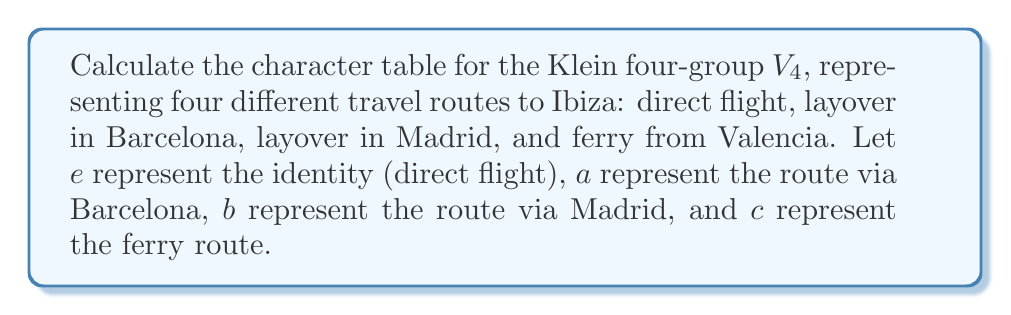Provide a solution to this math problem. To calculate the character table for the Klein four-group $V_4$, we'll follow these steps:

1) First, identify the conjugacy classes of $V_4$:
   Since $V_4$ is abelian, each element forms its own conjugacy class.
   Conjugacy classes: $\{e\}$, $\{a\}$, $\{b\}$, $\{c\}$

2) Determine the number of irreducible representations:
   The number of irreducible representations equals the number of conjugacy classes, which is 4.

3) The sum of squares of the dimensions of irreducible representations must equal the order of the group:
   $d_1^2 + d_2^2 + d_3^2 + d_4^2 = |V_4| = 4$

4) For an abelian group, all irreducible representations are 1-dimensional. So, we have four 1-dimensional representations.

5) Construct the character table:
   - The first row (trivial representation) is always all 1's.
   - For the remaining rows, we need to ensure orthogonality and that the characters form a group homomorphism.

6) The character table will look like this:

   $$\begin{array}{c|cccc}
      V_4 & e & a & b & c \\
      \hline
      \chi_1 & 1 & 1 & 1 & 1 \\
      \chi_2 & 1 & 1 & -1 & -1 \\
      \chi_3 & 1 & -1 & 1 & -1 \\
      \chi_4 & 1 & -1 & -1 & 1
   \end{array}$$

7) Verify orthogonality of rows and columns.

This character table represents how each "travel route" (group element) behaves under different representations, analogous to how a traveler might experience different aspects of the journey to Ibiza depending on the chosen route.
Answer: $$\begin{array}{c|cccc}
   V_4 & e & a & b & c \\
   \hline
   \chi_1 & 1 & 1 & 1 & 1 \\
   \chi_2 & 1 & 1 & -1 & -1 \\
   \chi_3 & 1 & -1 & 1 & -1 \\
   \chi_4 & 1 & -1 & -1 & 1
\end{array}$$ 